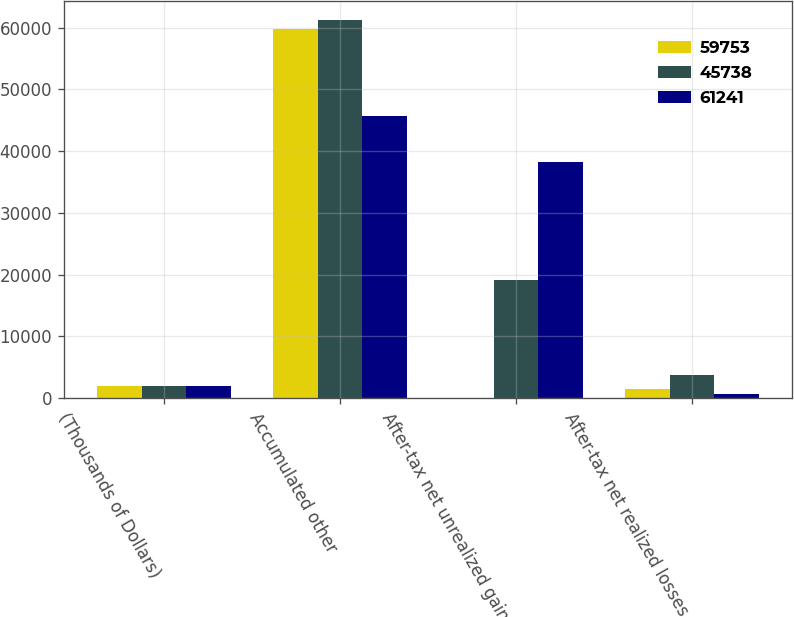<chart> <loc_0><loc_0><loc_500><loc_500><stacked_bar_chart><ecel><fcel>(Thousands of Dollars)<fcel>Accumulated other<fcel>After-tax net unrealized gains<fcel>After-tax net realized losses<nl><fcel>59753<fcel>2013<fcel>59753<fcel>12<fcel>1476<nl><fcel>45738<fcel>2012<fcel>61241<fcel>19200<fcel>3697<nl><fcel>61241<fcel>2011<fcel>45738<fcel>38292<fcel>648<nl></chart> 